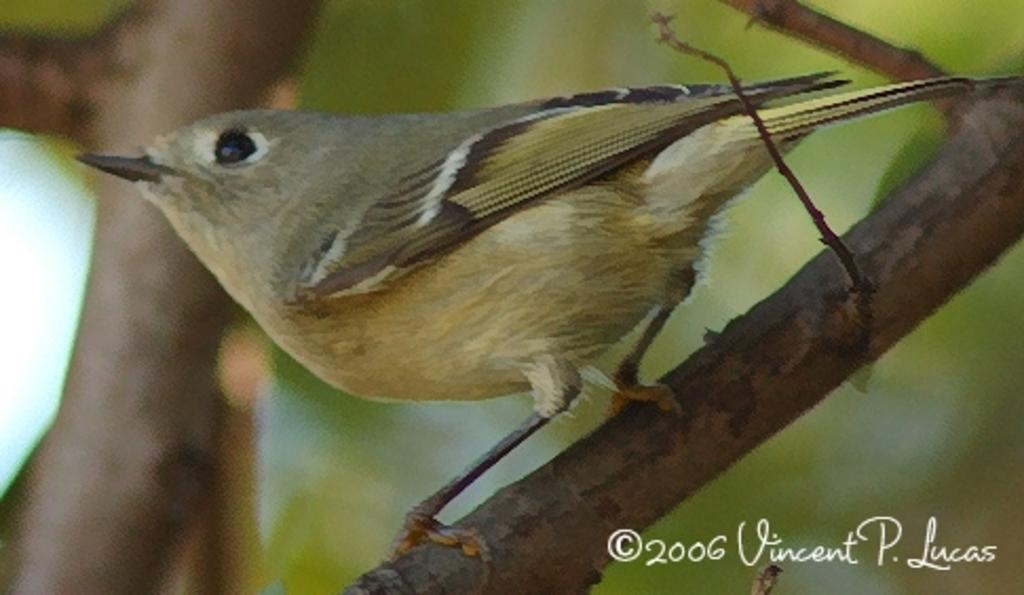What type of animal can be seen in the image? There is a bird in the image. Where is the bird located? The bird is standing on a branch of a tree. Can you describe the background of the image? The background of the image is blurry. What type of harmony is the bird singing in the image? The image does not show the bird singing, and therefore it cannot be determined what type of harmony it might be singing. 